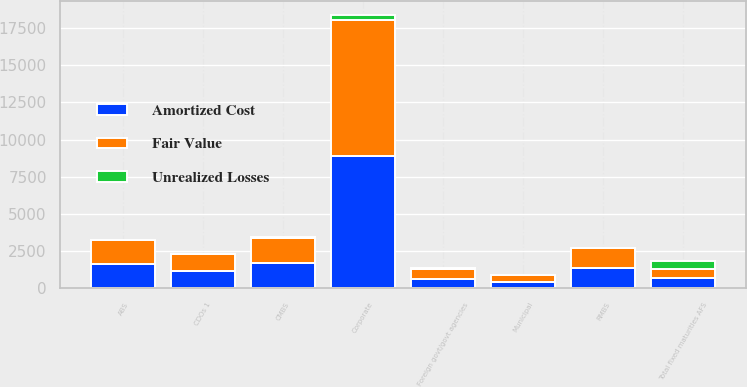Convert chart to OTSL. <chart><loc_0><loc_0><loc_500><loc_500><stacked_bar_chart><ecel><fcel>ABS<fcel>CDOs 1<fcel>CMBS<fcel>Corporate<fcel>Foreign govt/govt agencies<fcel>Municipal<fcel>RMBS<fcel>Total fixed maturities AFS<nl><fcel>Fair Value<fcel>1619<fcel>1164<fcel>1726<fcel>9206<fcel>679<fcel>440<fcel>1349<fcel>662.5<nl><fcel>Amortized Cost<fcel>1609<fcel>1154<fcel>1681<fcel>8866<fcel>646<fcel>430<fcel>1340<fcel>662.5<nl><fcel>Unrealized Losses<fcel>10<fcel>10<fcel>45<fcel>340<fcel>33<fcel>10<fcel>9<fcel>495<nl></chart> 